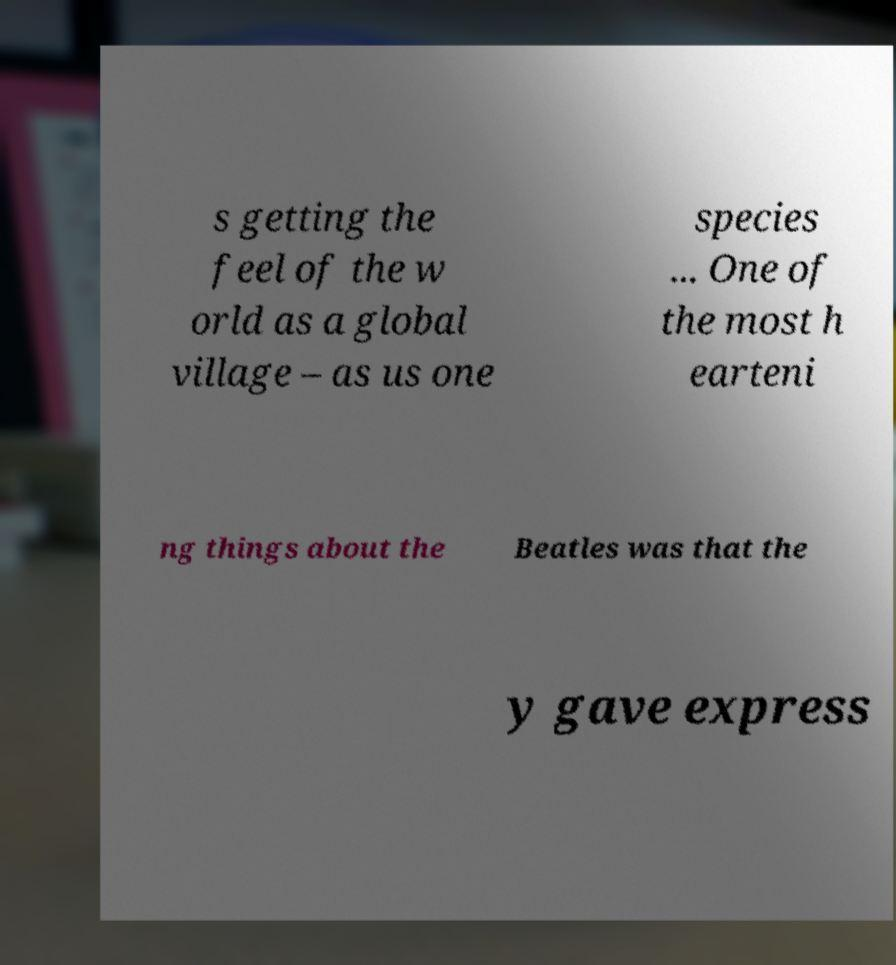For documentation purposes, I need the text within this image transcribed. Could you provide that? s getting the feel of the w orld as a global village – as us one species ... One of the most h earteni ng things about the Beatles was that the y gave express 